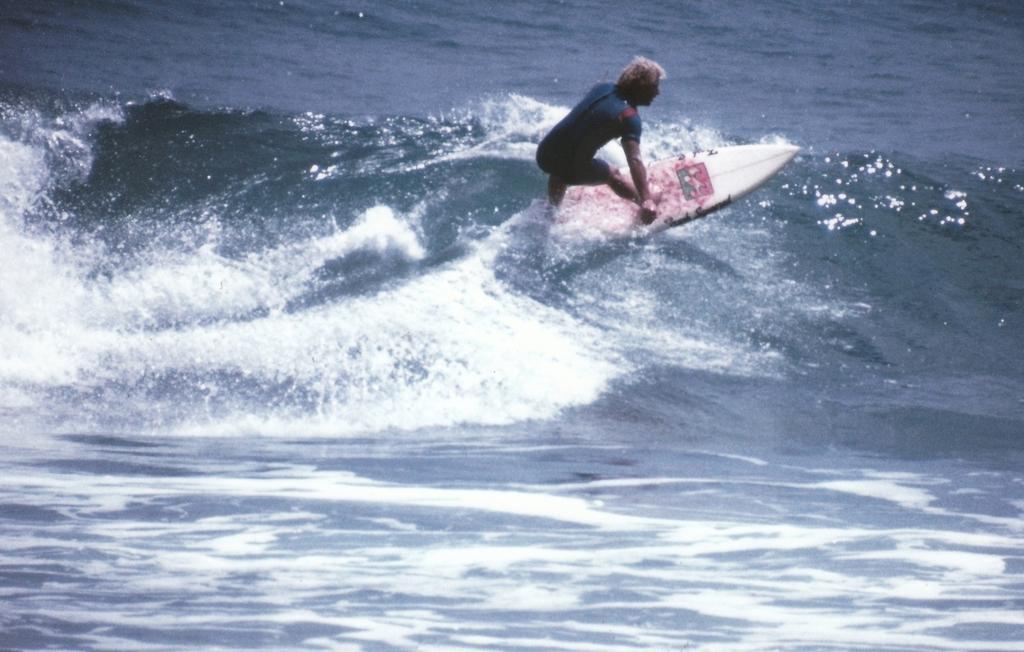Please provide a concise description of this image. In the image in the center we can see one person surfing on the water. 